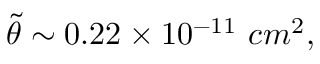Convert formula to latex. <formula><loc_0><loc_0><loc_500><loc_500>{ \tilde { \theta } } \sim 0 . 2 2 \times 1 0 ^ { - 1 1 } \, c m ^ { 2 } ,</formula> 